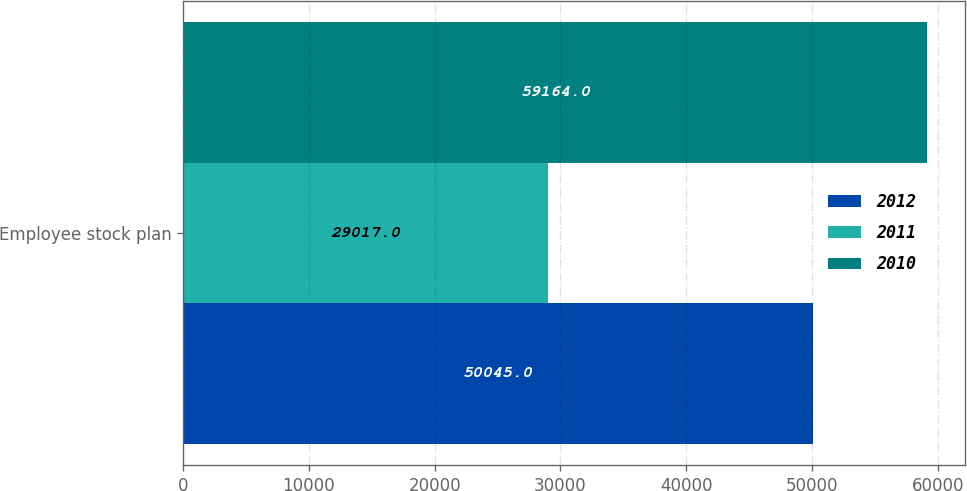<chart> <loc_0><loc_0><loc_500><loc_500><stacked_bar_chart><ecel><fcel>Employee stock plan<nl><fcel>2012<fcel>50045<nl><fcel>2011<fcel>29017<nl><fcel>2010<fcel>59164<nl></chart> 